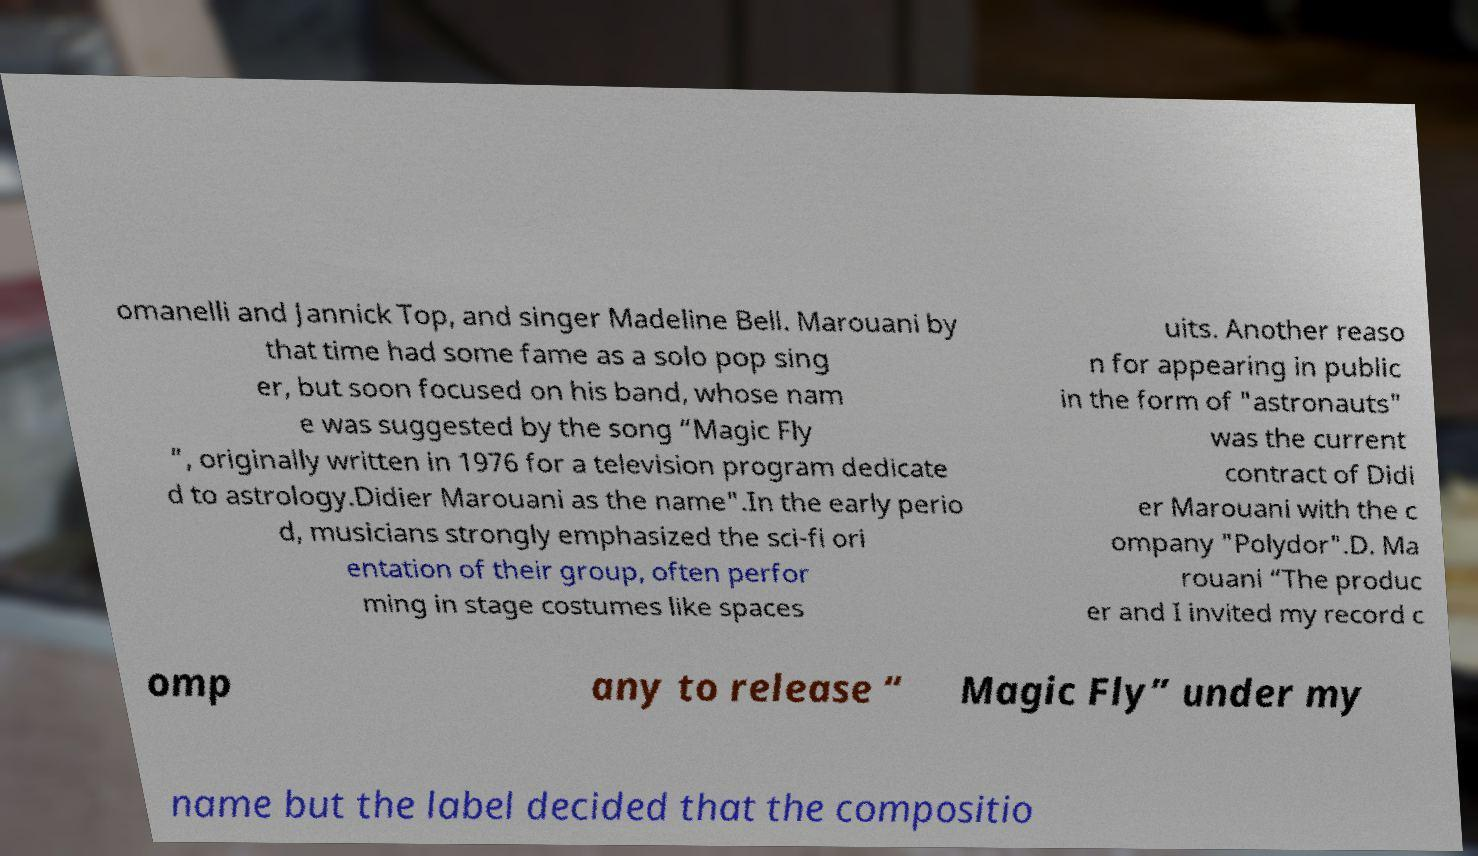Can you read and provide the text displayed in the image?This photo seems to have some interesting text. Can you extract and type it out for me? omanelli and Jannick Top, and singer Madeline Bell. Marouani by that time had some fame as a solo pop sing er, but soon focused on his band, whose nam e was suggested by the song “Magic Fly ”, originally written in 1976 for a television program dedicate d to astrology.Didier Marouani as the name".In the early perio d, musicians strongly emphasized the sci-fi ori entation of their group, often perfor ming in stage costumes like spaces uits. Another reaso n for appearing in public in the form of "astronauts" was the current contract of Didi er Marouani with the c ompany "Polydor".D. Ma rouani “The produc er and I invited my record c omp any to release “ Magic Fly” under my name but the label decided that the compositio 